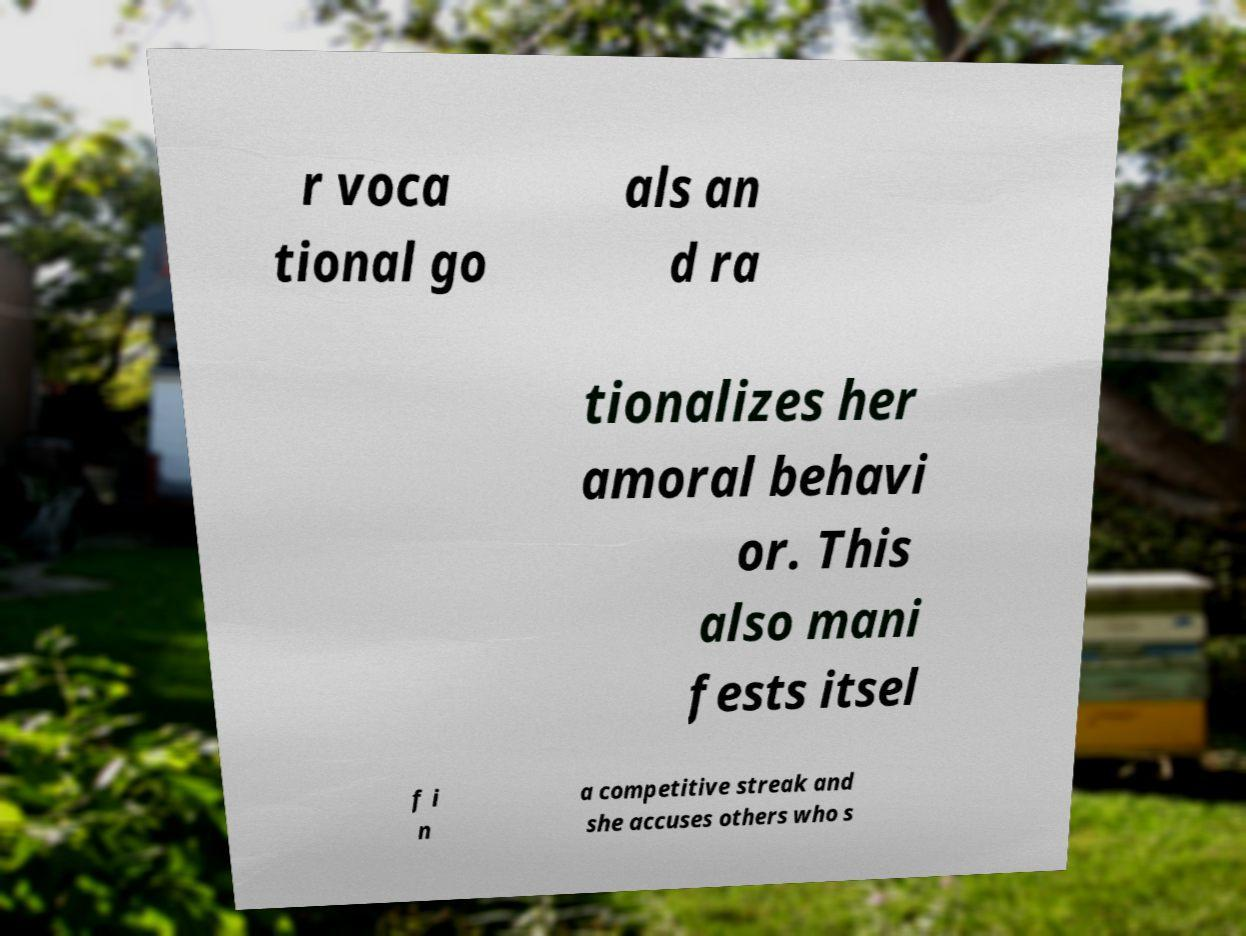What messages or text are displayed in this image? I need them in a readable, typed format. r voca tional go als an d ra tionalizes her amoral behavi or. This also mani fests itsel f i n a competitive streak and she accuses others who s 